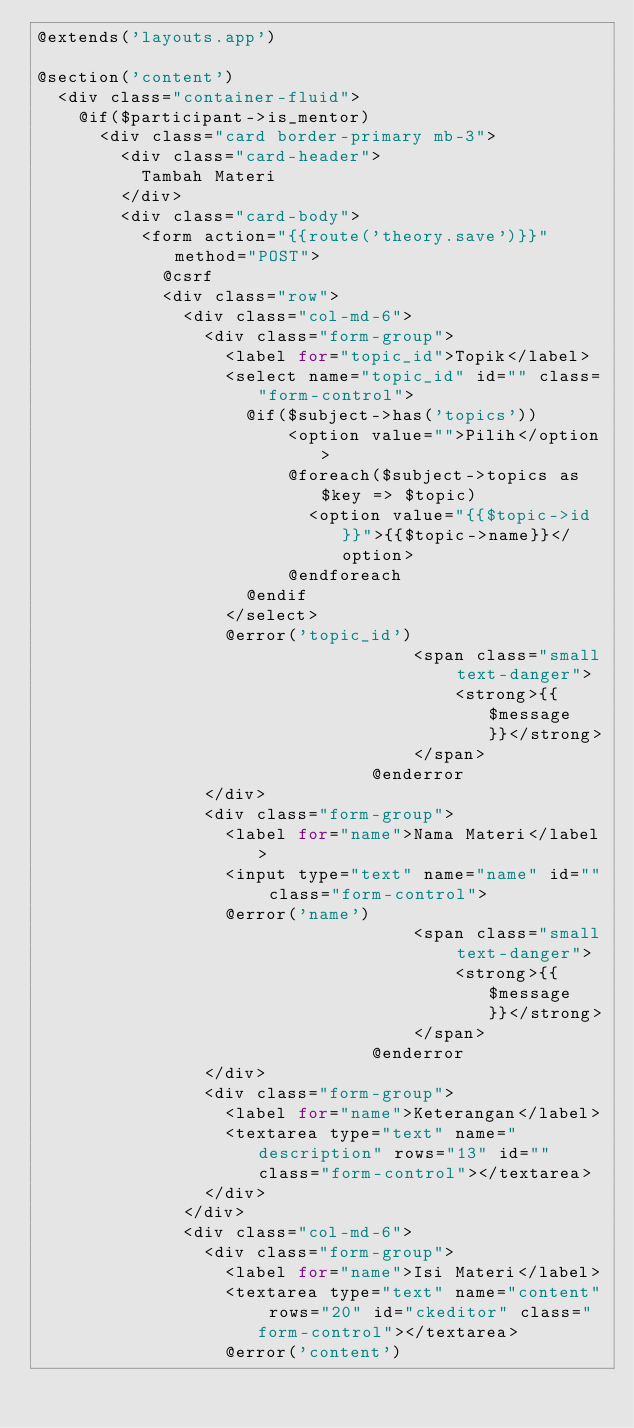Convert code to text. <code><loc_0><loc_0><loc_500><loc_500><_PHP_>@extends('layouts.app')

@section('content')
	<div class="container-fluid">
		@if($participant->is_mentor)
			<div class="card border-primary mb-3">
			 	<div class="card-header">
				 	Tambah Materi
			 	</div>
			 	<div class="card-body">
					<form action="{{route('theory.save')}}" method="POST">
						@csrf
						<div class="row">
							<div class="col-md-6">
								<div class="form-group">
									<label for="topic_id">Topik</label>
									<select name="topic_id" id="" class="form-control">
										@if($subject->has('topics'))
												<option value="">Pilih</option>
												@foreach($subject->topics as $key => $topic)
													<option value="{{$topic->id}}">{{$topic->name}}</option>
												@endforeach
										@endif
									</select>
									@error('topic_id')
		                                <span class="small text-danger">
		                                    <strong>{{$message}}</strong>
		                                </span>
		                            @enderror
								</div>
								<div class="form-group">
									<label for="name">Nama Materi</label>
									<input type="text" name="name" id="" class="form-control">
									@error('name')
		                                <span class="small text-danger">
		                                    <strong>{{$message}}</strong>
		                                </span>
		                            @enderror
								</div>
								<div class="form-group">
									<label for="name">Keterangan</label>
									<textarea type="text" name="description" rows="13" id="" class="form-control"></textarea>
								</div>
							</div>
							<div class="col-md-6">
								<div class="form-group">
									<label for="name">Isi Materi</label>
									<textarea type="text" name="content" rows="20" id="ckeditor" class="form-control"></textarea>
									@error('content')</code> 